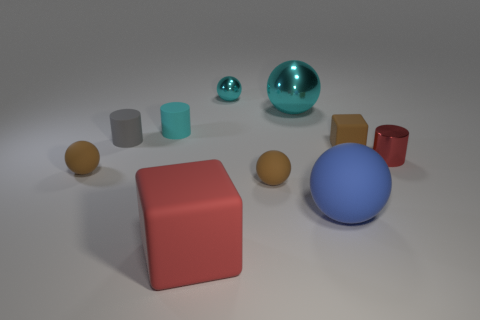Subtract all small metallic cylinders. How many cylinders are left? 2 Subtract 1 spheres. How many spheres are left? 4 Subtract all blue spheres. How many spheres are left? 4 Subtract all cubes. How many objects are left? 8 Subtract all brown balls. Subtract all green cubes. How many balls are left? 3 Subtract 0 purple balls. How many objects are left? 10 Subtract all cyan cylinders. Subtract all large red rubber cylinders. How many objects are left? 9 Add 1 large red rubber things. How many large red rubber things are left? 2 Add 4 small green things. How many small green things exist? 4 